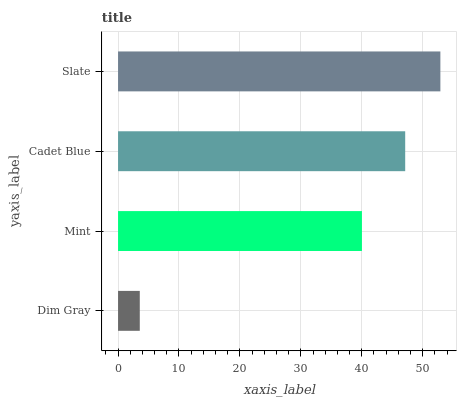Is Dim Gray the minimum?
Answer yes or no. Yes. Is Slate the maximum?
Answer yes or no. Yes. Is Mint the minimum?
Answer yes or no. No. Is Mint the maximum?
Answer yes or no. No. Is Mint greater than Dim Gray?
Answer yes or no. Yes. Is Dim Gray less than Mint?
Answer yes or no. Yes. Is Dim Gray greater than Mint?
Answer yes or no. No. Is Mint less than Dim Gray?
Answer yes or no. No. Is Cadet Blue the high median?
Answer yes or no. Yes. Is Mint the low median?
Answer yes or no. Yes. Is Slate the high median?
Answer yes or no. No. Is Slate the low median?
Answer yes or no. No. 